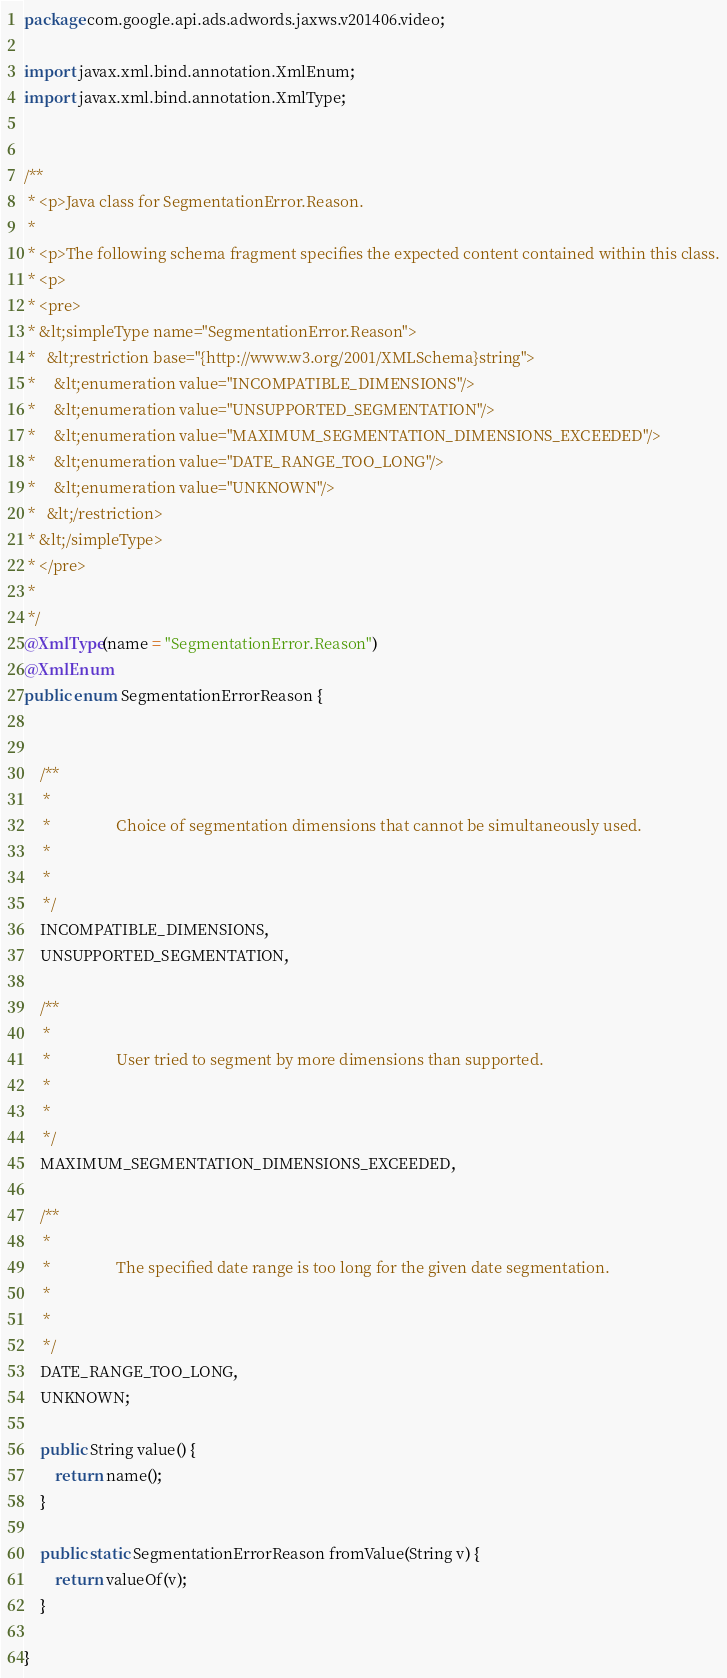<code> <loc_0><loc_0><loc_500><loc_500><_Java_>
package com.google.api.ads.adwords.jaxws.v201406.video;

import javax.xml.bind.annotation.XmlEnum;
import javax.xml.bind.annotation.XmlType;


/**
 * <p>Java class for SegmentationError.Reason.
 * 
 * <p>The following schema fragment specifies the expected content contained within this class.
 * <p>
 * <pre>
 * &lt;simpleType name="SegmentationError.Reason">
 *   &lt;restriction base="{http://www.w3.org/2001/XMLSchema}string">
 *     &lt;enumeration value="INCOMPATIBLE_DIMENSIONS"/>
 *     &lt;enumeration value="UNSUPPORTED_SEGMENTATION"/>
 *     &lt;enumeration value="MAXIMUM_SEGMENTATION_DIMENSIONS_EXCEEDED"/>
 *     &lt;enumeration value="DATE_RANGE_TOO_LONG"/>
 *     &lt;enumeration value="UNKNOWN"/>
 *   &lt;/restriction>
 * &lt;/simpleType>
 * </pre>
 * 
 */
@XmlType(name = "SegmentationError.Reason")
@XmlEnum
public enum SegmentationErrorReason {


    /**
     * 
     *                 Choice of segmentation dimensions that cannot be simultaneously used.
     *               
     * 
     */
    INCOMPATIBLE_DIMENSIONS,
    UNSUPPORTED_SEGMENTATION,

    /**
     * 
     *                 User tried to segment by more dimensions than supported.
     *               
     * 
     */
    MAXIMUM_SEGMENTATION_DIMENSIONS_EXCEEDED,

    /**
     * 
     *                 The specified date range is too long for the given date segmentation.
     *               
     * 
     */
    DATE_RANGE_TOO_LONG,
    UNKNOWN;

    public String value() {
        return name();
    }

    public static SegmentationErrorReason fromValue(String v) {
        return valueOf(v);
    }

}
</code> 